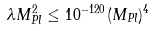<formula> <loc_0><loc_0><loc_500><loc_500>\lambda M _ { P l } ^ { 2 } \leq 1 0 ^ { - 1 2 0 } ( M _ { P l } ) ^ { 4 }</formula> 